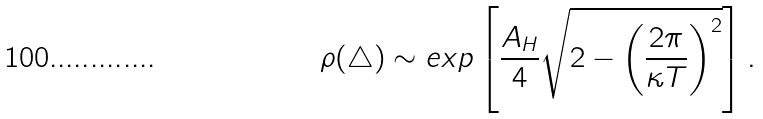Convert formula to latex. <formula><loc_0><loc_0><loc_500><loc_500>\rho ( \triangle ) \sim e x p \left [ \frac { A _ { H } } { 4 } \sqrt { 2 - \left ( \frac { 2 \pi } { \kappa T } \right ) ^ { 2 } } \right ] .</formula> 